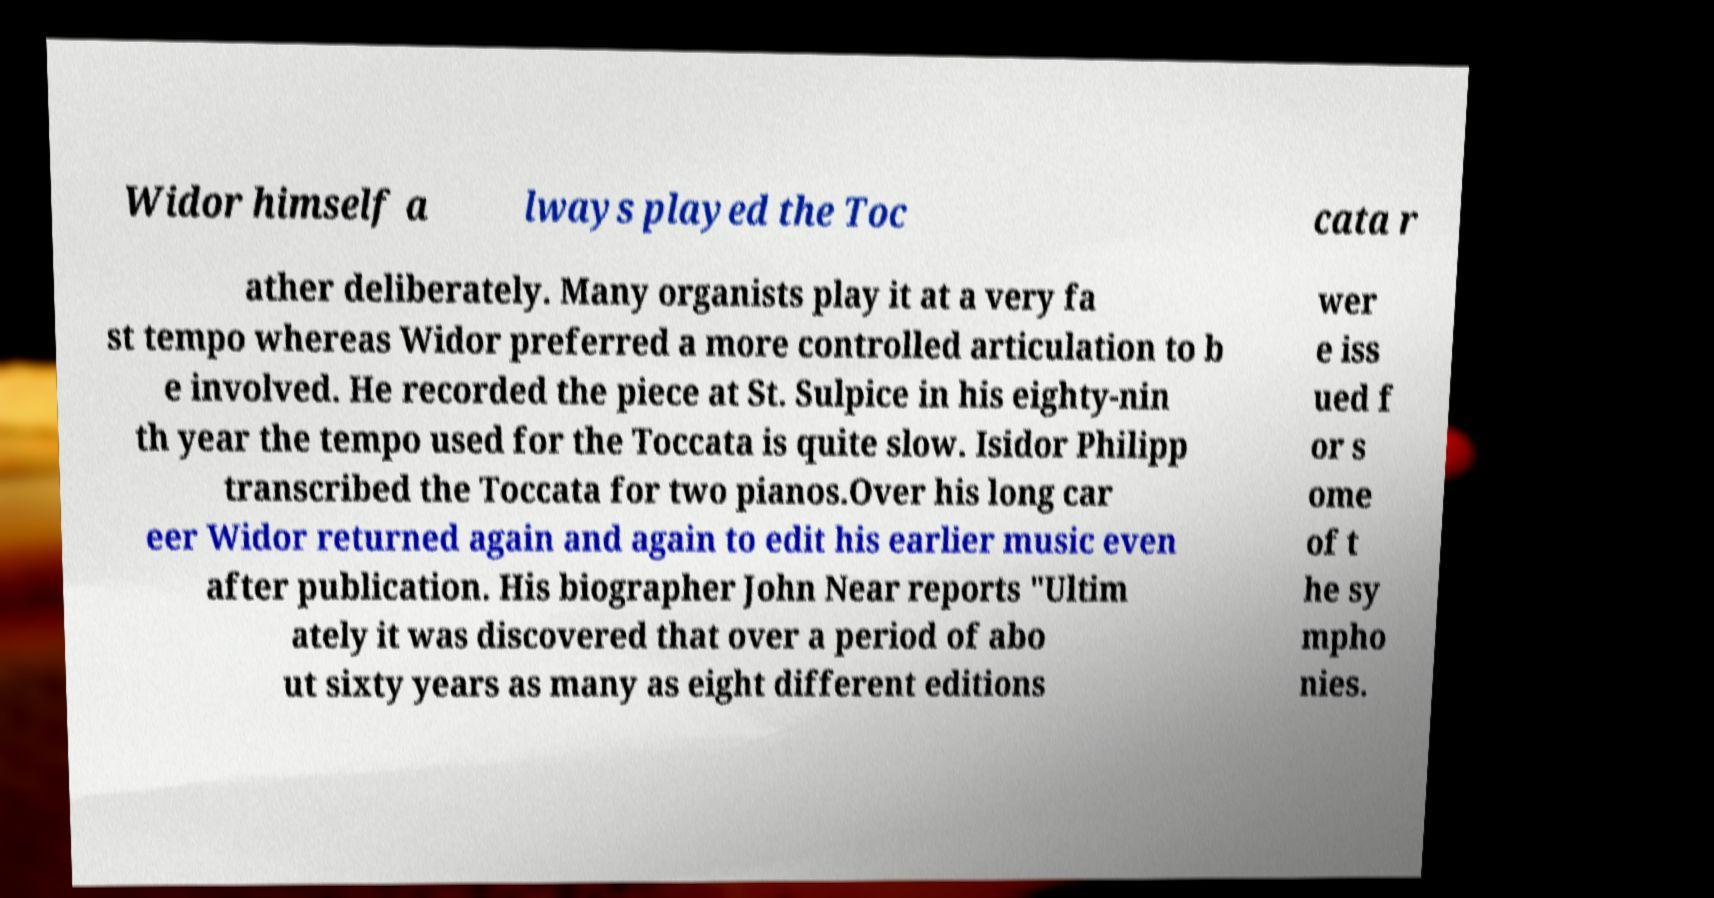For documentation purposes, I need the text within this image transcribed. Could you provide that? Widor himself a lways played the Toc cata r ather deliberately. Many organists play it at a very fa st tempo whereas Widor preferred a more controlled articulation to b e involved. He recorded the piece at St. Sulpice in his eighty-nin th year the tempo used for the Toccata is quite slow. Isidor Philipp transcribed the Toccata for two pianos.Over his long car eer Widor returned again and again to edit his earlier music even after publication. His biographer John Near reports "Ultim ately it was discovered that over a period of abo ut sixty years as many as eight different editions wer e iss ued f or s ome of t he sy mpho nies. 